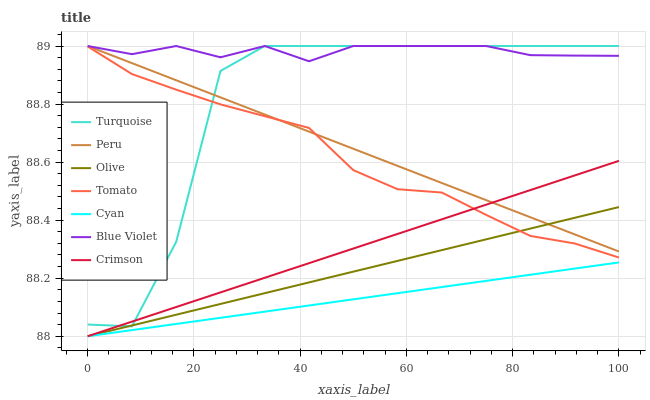Does Cyan have the minimum area under the curve?
Answer yes or no. Yes. Does Blue Violet have the maximum area under the curve?
Answer yes or no. Yes. Does Turquoise have the minimum area under the curve?
Answer yes or no. No. Does Turquoise have the maximum area under the curve?
Answer yes or no. No. Is Cyan the smoothest?
Answer yes or no. Yes. Is Turquoise the roughest?
Answer yes or no. Yes. Is Crimson the smoothest?
Answer yes or no. No. Is Crimson the roughest?
Answer yes or no. No. Does Crimson have the lowest value?
Answer yes or no. Yes. Does Turquoise have the lowest value?
Answer yes or no. No. Does Blue Violet have the highest value?
Answer yes or no. Yes. Does Crimson have the highest value?
Answer yes or no. No. Is Cyan less than Blue Violet?
Answer yes or no. Yes. Is Blue Violet greater than Tomato?
Answer yes or no. Yes. Does Crimson intersect Olive?
Answer yes or no. Yes. Is Crimson less than Olive?
Answer yes or no. No. Is Crimson greater than Olive?
Answer yes or no. No. Does Cyan intersect Blue Violet?
Answer yes or no. No. 